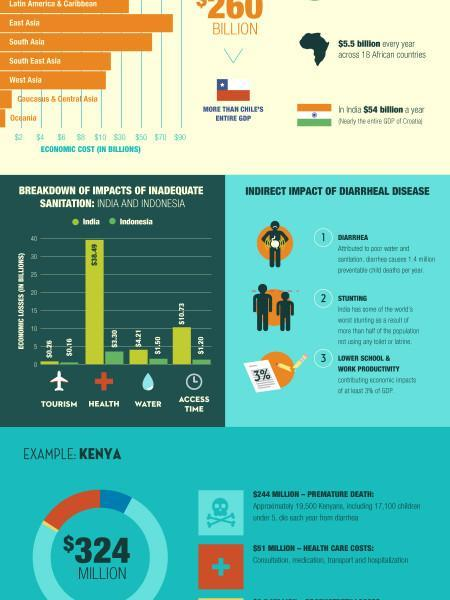Which country suffers bigger economic loss in health sector?
Answer the question with a short phrase. India 